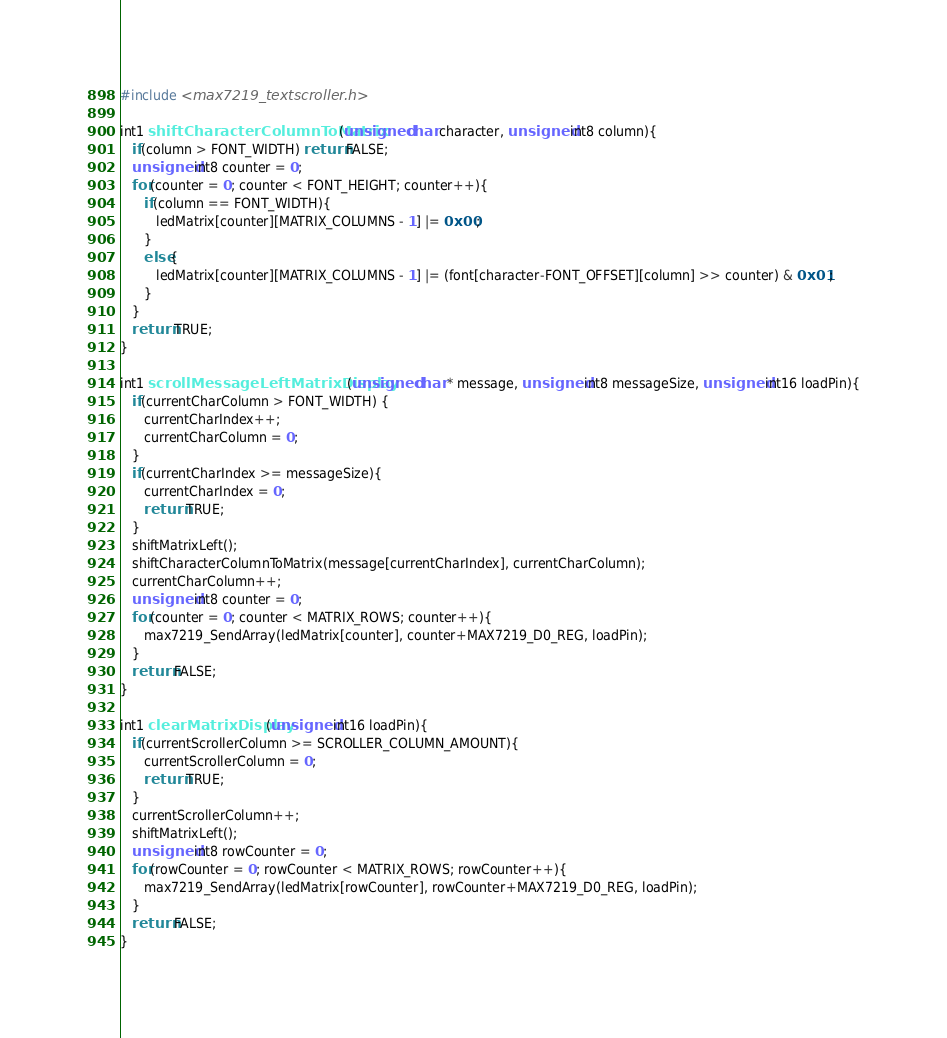Convert code to text. <code><loc_0><loc_0><loc_500><loc_500><_C_>#include <max7219_textscroller.h>

int1 shiftCharacterColumnToMatrix(unsigned char character, unsigned int8 column){
   if(column > FONT_WIDTH) return FALSE;
   unsigned int8 counter = 0;
   for(counter = 0; counter < FONT_HEIGHT; counter++){
      if(column == FONT_WIDTH){
         ledMatrix[counter][MATRIX_COLUMNS - 1] |= 0x00;
      }
      else{
         ledMatrix[counter][MATRIX_COLUMNS - 1] |= (font[character-FONT_OFFSET][column] >> counter) & 0x01; 
      }
   }
   return TRUE;
}

int1 scrollMessageLeftMatrixDisplay(unsigned char * message, unsigned int8 messageSize, unsigned int16 loadPin){
   if(currentCharColumn > FONT_WIDTH) {
      currentCharIndex++;
      currentCharColumn = 0;
   }
   if(currentCharIndex >= messageSize){
      currentCharIndex = 0;
      return TRUE;
   }
   shiftMatrixLeft();
   shiftCharacterColumnToMatrix(message[currentCharIndex], currentCharColumn);
   currentCharColumn++;
   unsigned int8 counter = 0;
   for(counter = 0; counter < MATRIX_ROWS; counter++){
      max7219_SendArray(ledMatrix[counter], counter+MAX7219_D0_REG, loadPin);
   }
   return FALSE;
}

int1 clearMatrixDisplay(unsigned int16 loadPin){
   if(currentScrollerColumn >= SCROLLER_COLUMN_AMOUNT){
      currentScrollerColumn = 0;
      return TRUE;
   }
   currentScrollerColumn++;
   shiftMatrixLeft();
   unsigned int8 rowCounter = 0;
   for(rowCounter = 0; rowCounter < MATRIX_ROWS; rowCounter++){
      max7219_SendArray(ledMatrix[rowCounter], rowCounter+MAX7219_D0_REG, loadPin);
   }
   return FALSE;
}
</code> 